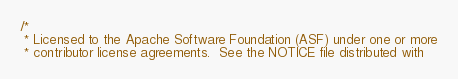Convert code to text. <code><loc_0><loc_0><loc_500><loc_500><_Scala_>/*
 * Licensed to the Apache Software Foundation (ASF) under one or more
 * contributor license agreements.  See the NOTICE file distributed with</code> 